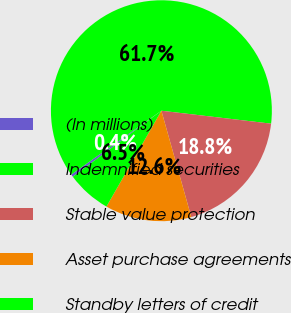<chart> <loc_0><loc_0><loc_500><loc_500><pie_chart><fcel>(In millions)<fcel>Indemnified securities<fcel>Stable value protection<fcel>Asset purchase agreements<fcel>Standby letters of credit<nl><fcel>0.39%<fcel>61.68%<fcel>18.77%<fcel>12.65%<fcel>6.52%<nl></chart> 